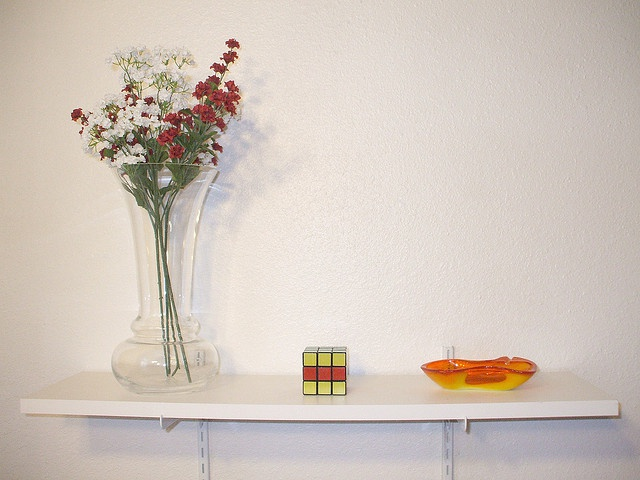Describe the objects in this image and their specific colors. I can see vase in darkgray, lightgray, and tan tones and bowl in darkgray, red, orange, and brown tones in this image. 